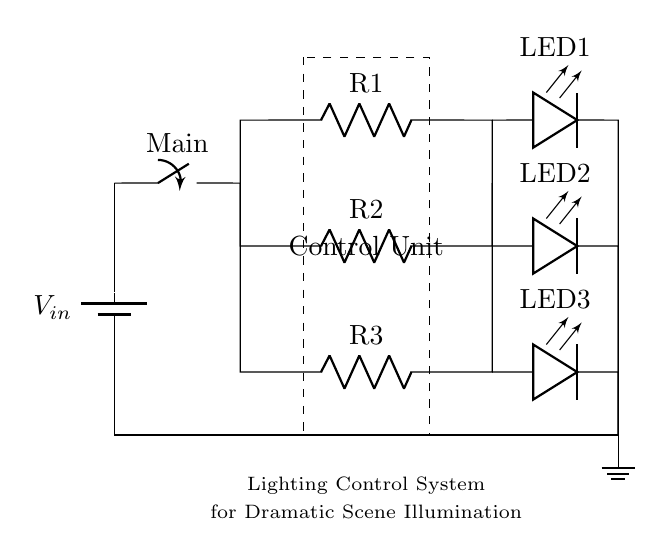What is the power supply in this circuit? The power supply is a battery, indicated by the symbol at the top left of the diagram, marked as Vin.
Answer: battery How many resistors are in the circuit? There are three resistors present in the circuit, labeled R1, R2, and R3, which are connected in parallel.
Answer: three What role does the control unit play? The control unit specifies the function of the lighting system, indicated by the dashed rectangle, that manages the overall operation of the LEDs and resistors.
Answer: management How are the LEDs connected in the circuit? The LEDs are connected in parallel through separate branches, allowing each LED (LED1, LED2, LED3) to operate independently while sharing the same voltage from the power supply.
Answer: parallel What type of circuit is this? This is a parallel circuit, as evidenced by the arrangement of components where multiple paths allow for the independent operation of LEDs and resistors.
Answer: parallel What is the purpose of the resistors in this configuration? The resistors limit the current flowing through the LEDs, preventing them from receiving excessive current that could lead to failure or damage.
Answer: current limiting Which component turns the circuit on and off? The main switch, located between the power supply and the parallel branches, is responsible for turning the circuit on and off as indicated by its position in the circuit.
Answer: main switch 